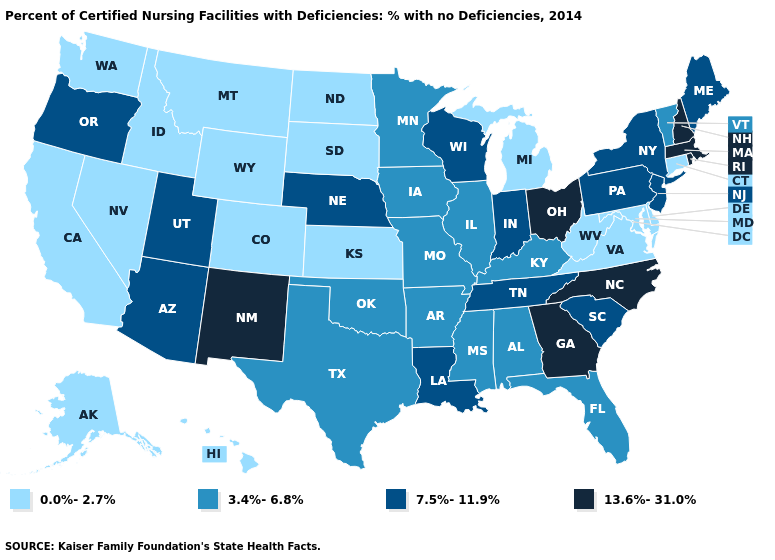Does New Hampshire have the highest value in the USA?
Write a very short answer. Yes. Name the states that have a value in the range 3.4%-6.8%?
Give a very brief answer. Alabama, Arkansas, Florida, Illinois, Iowa, Kentucky, Minnesota, Mississippi, Missouri, Oklahoma, Texas, Vermont. How many symbols are there in the legend?
Keep it brief. 4. Does New York have the lowest value in the USA?
Be succinct. No. What is the value of Vermont?
Be succinct. 3.4%-6.8%. Is the legend a continuous bar?
Answer briefly. No. Name the states that have a value in the range 3.4%-6.8%?
Answer briefly. Alabama, Arkansas, Florida, Illinois, Iowa, Kentucky, Minnesota, Mississippi, Missouri, Oklahoma, Texas, Vermont. Name the states that have a value in the range 13.6%-31.0%?
Quick response, please. Georgia, Massachusetts, New Hampshire, New Mexico, North Carolina, Ohio, Rhode Island. Name the states that have a value in the range 3.4%-6.8%?
Short answer required. Alabama, Arkansas, Florida, Illinois, Iowa, Kentucky, Minnesota, Mississippi, Missouri, Oklahoma, Texas, Vermont. What is the value of Louisiana?
Be succinct. 7.5%-11.9%. Name the states that have a value in the range 0.0%-2.7%?
Concise answer only. Alaska, California, Colorado, Connecticut, Delaware, Hawaii, Idaho, Kansas, Maryland, Michigan, Montana, Nevada, North Dakota, South Dakota, Virginia, Washington, West Virginia, Wyoming. Among the states that border Maryland , does Pennsylvania have the lowest value?
Keep it brief. No. Among the states that border Arkansas , does Mississippi have the highest value?
Short answer required. No. Name the states that have a value in the range 7.5%-11.9%?
Write a very short answer. Arizona, Indiana, Louisiana, Maine, Nebraska, New Jersey, New York, Oregon, Pennsylvania, South Carolina, Tennessee, Utah, Wisconsin. Does the map have missing data?
Short answer required. No. 